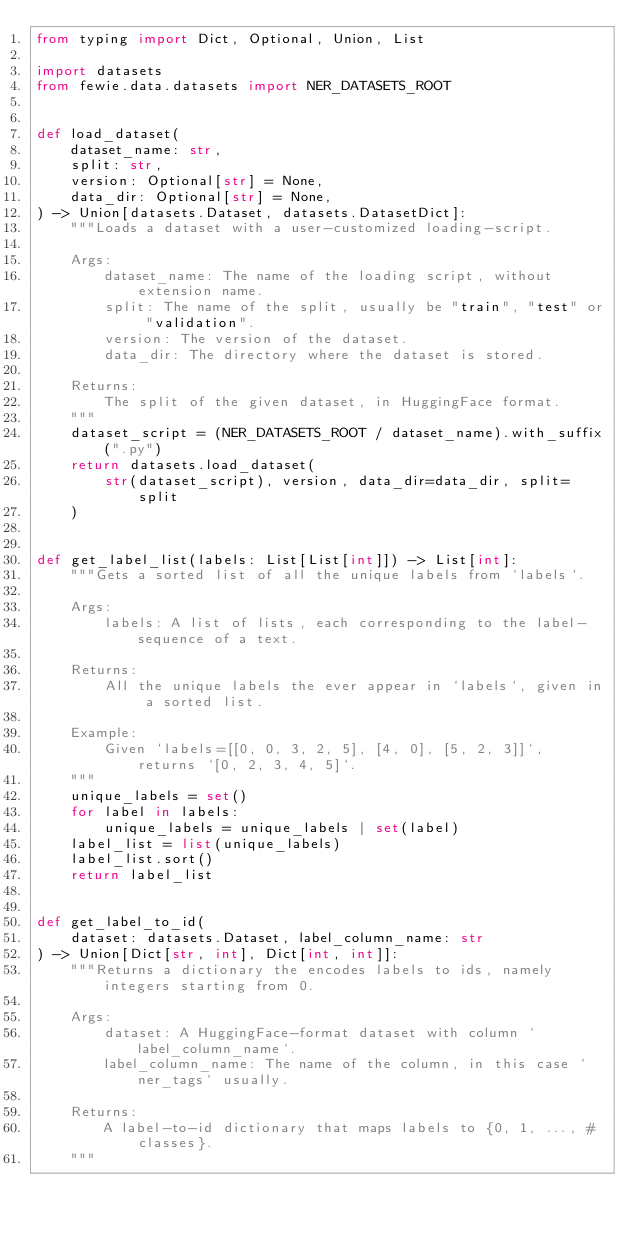<code> <loc_0><loc_0><loc_500><loc_500><_Python_>from typing import Dict, Optional, Union, List

import datasets
from fewie.data.datasets import NER_DATASETS_ROOT


def load_dataset(
    dataset_name: str,
    split: str,
    version: Optional[str] = None,
    data_dir: Optional[str] = None,
) -> Union[datasets.Dataset, datasets.DatasetDict]:
    """Loads a dataset with a user-customized loading-script.

    Args:
        dataset_name: The name of the loading script, without extension name.
        split: The name of the split, usually be "train", "test" or "validation".
        version: The version of the dataset.
        data_dir: The directory where the dataset is stored.

    Returns:
        The split of the given dataset, in HuggingFace format.
    """
    dataset_script = (NER_DATASETS_ROOT / dataset_name).with_suffix(".py")
    return datasets.load_dataset(
        str(dataset_script), version, data_dir=data_dir, split=split
    )


def get_label_list(labels: List[List[int]]) -> List[int]:
    """Gets a sorted list of all the unique labels from `labels`.

    Args:
        labels: A list of lists, each corresponding to the label-sequence of a text.

    Returns:
        All the unique labels the ever appear in `labels`, given in a sorted list.

    Example:
        Given `labels=[[0, 0, 3, 2, 5], [4, 0], [5, 2, 3]]`, returns `[0, 2, 3, 4, 5]`.
    """
    unique_labels = set()
    for label in labels:
        unique_labels = unique_labels | set(label)
    label_list = list(unique_labels)
    label_list.sort()
    return label_list


def get_label_to_id(
    dataset: datasets.Dataset, label_column_name: str
) -> Union[Dict[str, int], Dict[int, int]]:
    """Returns a dictionary the encodes labels to ids, namely integers starting from 0.

    Args:
        dataset: A HuggingFace-format dataset with column `label_column_name`.
        label_column_name: The name of the column, in this case `ner_tags` usually.

    Returns:
        A label-to-id dictionary that maps labels to {0, 1, ..., #classes}.
    """</code> 